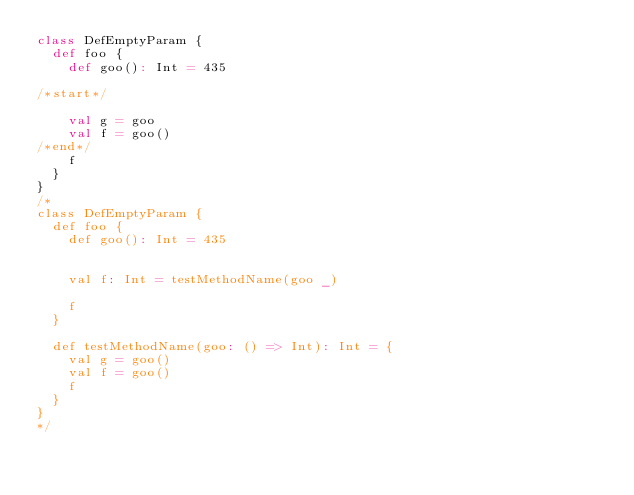Convert code to text. <code><loc_0><loc_0><loc_500><loc_500><_Scala_>class DefEmptyParam {
  def foo {
    def goo(): Int = 435

/*start*/

    val g = goo
    val f = goo()
/*end*/
    f
  }
}
/*
class DefEmptyParam {
  def foo {
    def goo(): Int = 435


    val f: Int = testMethodName(goo _)

    f
  }

  def testMethodName(goo: () => Int): Int = {
    val g = goo()
    val f = goo()
    f
  }
}
*/</code> 